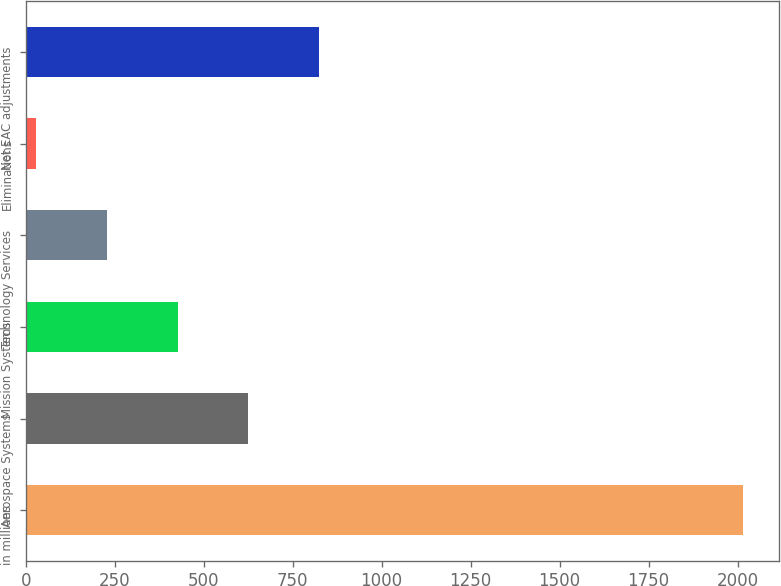Convert chart. <chart><loc_0><loc_0><loc_500><loc_500><bar_chart><fcel>in millions<fcel>Aerospace Systems<fcel>Mission Systems<fcel>Technology Services<fcel>Eliminations<fcel>Net EAC adjustments<nl><fcel>2016<fcel>625.1<fcel>426.4<fcel>227.7<fcel>29<fcel>823.8<nl></chart> 